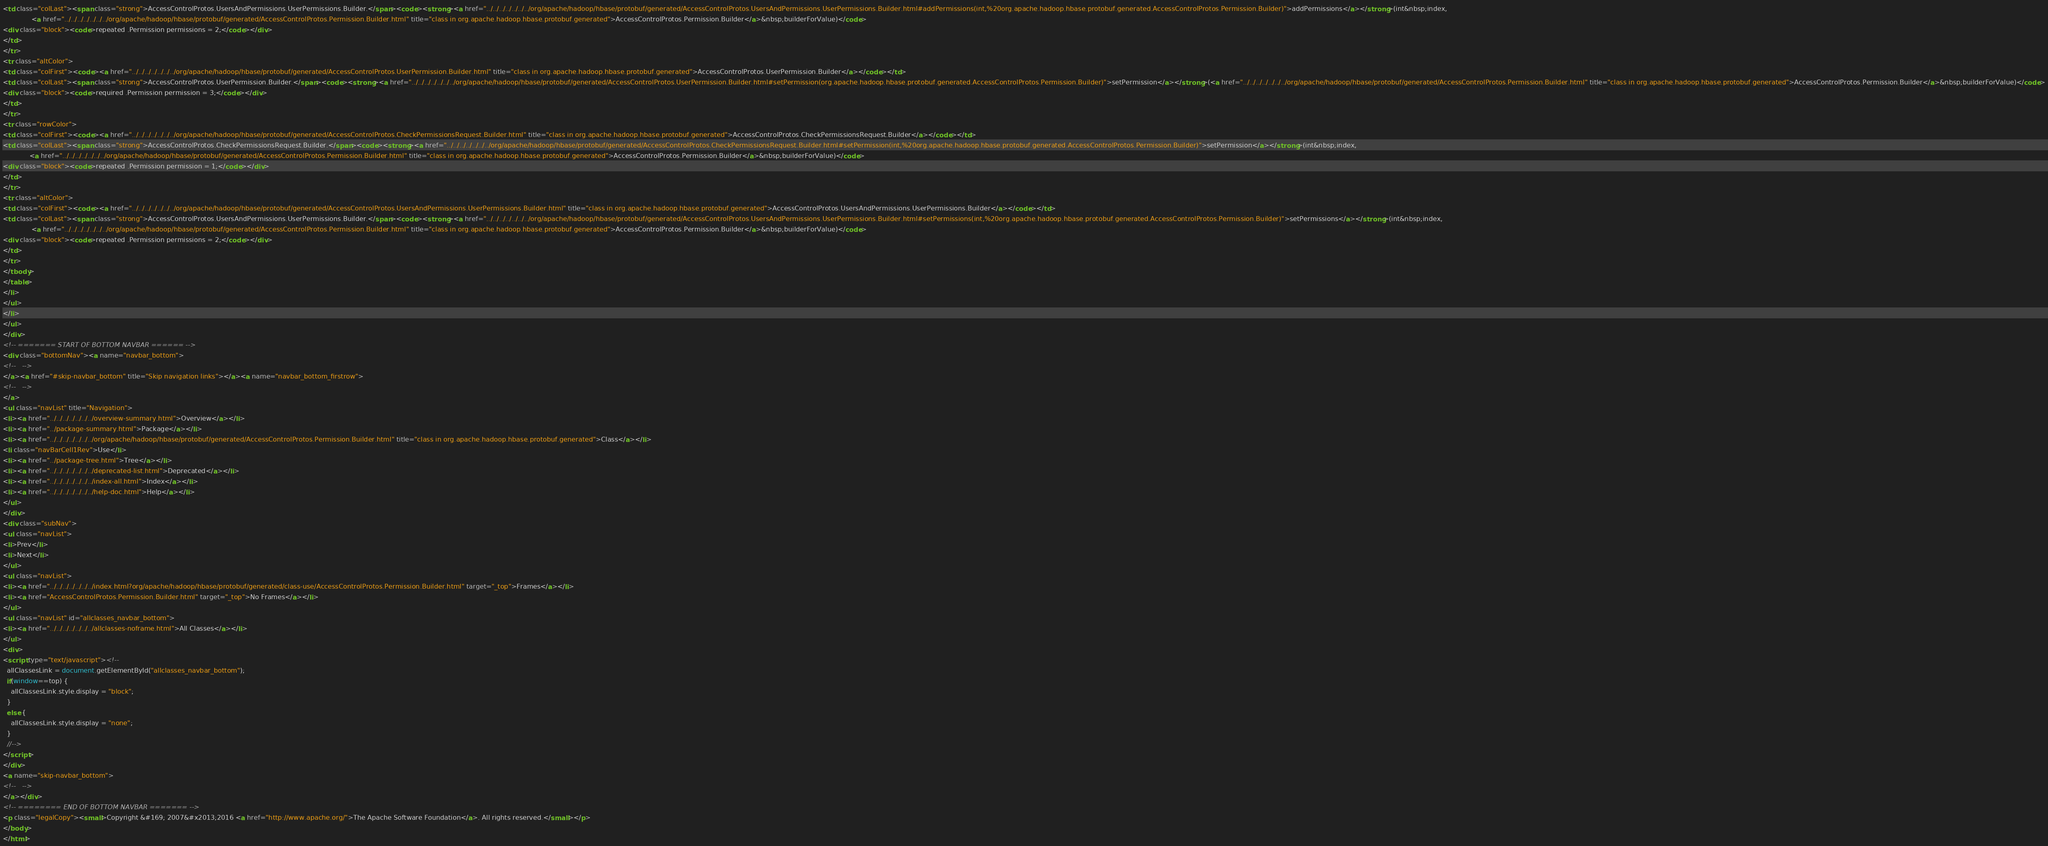<code> <loc_0><loc_0><loc_500><loc_500><_HTML_><td class="colLast"><span class="strong">AccessControlProtos.UsersAndPermissions.UserPermissions.Builder.</span><code><strong><a href="../../../../../../../org/apache/hadoop/hbase/protobuf/generated/AccessControlProtos.UsersAndPermissions.UserPermissions.Builder.html#addPermissions(int,%20org.apache.hadoop.hbase.protobuf.generated.AccessControlProtos.Permission.Builder)">addPermissions</a></strong>(int&nbsp;index,
              <a href="../../../../../../../org/apache/hadoop/hbase/protobuf/generated/AccessControlProtos.Permission.Builder.html" title="class in org.apache.hadoop.hbase.protobuf.generated">AccessControlProtos.Permission.Builder</a>&nbsp;builderForValue)</code>
<div class="block"><code>repeated .Permission permissions = 2;</code></div>
</td>
</tr>
<tr class="altColor">
<td class="colFirst"><code><a href="../../../../../../../org/apache/hadoop/hbase/protobuf/generated/AccessControlProtos.UserPermission.Builder.html" title="class in org.apache.hadoop.hbase.protobuf.generated">AccessControlProtos.UserPermission.Builder</a></code></td>
<td class="colLast"><span class="strong">AccessControlProtos.UserPermission.Builder.</span><code><strong><a href="../../../../../../../org/apache/hadoop/hbase/protobuf/generated/AccessControlProtos.UserPermission.Builder.html#setPermission(org.apache.hadoop.hbase.protobuf.generated.AccessControlProtos.Permission.Builder)">setPermission</a></strong>(<a href="../../../../../../../org/apache/hadoop/hbase/protobuf/generated/AccessControlProtos.Permission.Builder.html" title="class in org.apache.hadoop.hbase.protobuf.generated">AccessControlProtos.Permission.Builder</a>&nbsp;builderForValue)</code>
<div class="block"><code>required .Permission permission = 3;</code></div>
</td>
</tr>
<tr class="rowColor">
<td class="colFirst"><code><a href="../../../../../../../org/apache/hadoop/hbase/protobuf/generated/AccessControlProtos.CheckPermissionsRequest.Builder.html" title="class in org.apache.hadoop.hbase.protobuf.generated">AccessControlProtos.CheckPermissionsRequest.Builder</a></code></td>
<td class="colLast"><span class="strong">AccessControlProtos.CheckPermissionsRequest.Builder.</span><code><strong><a href="../../../../../../../org/apache/hadoop/hbase/protobuf/generated/AccessControlProtos.CheckPermissionsRequest.Builder.html#setPermission(int,%20org.apache.hadoop.hbase.protobuf.generated.AccessControlProtos.Permission.Builder)">setPermission</a></strong>(int&nbsp;index,
             <a href="../../../../../../../org/apache/hadoop/hbase/protobuf/generated/AccessControlProtos.Permission.Builder.html" title="class in org.apache.hadoop.hbase.protobuf.generated">AccessControlProtos.Permission.Builder</a>&nbsp;builderForValue)</code>
<div class="block"><code>repeated .Permission permission = 1;</code></div>
</td>
</tr>
<tr class="altColor">
<td class="colFirst"><code><a href="../../../../../../../org/apache/hadoop/hbase/protobuf/generated/AccessControlProtos.UsersAndPermissions.UserPermissions.Builder.html" title="class in org.apache.hadoop.hbase.protobuf.generated">AccessControlProtos.UsersAndPermissions.UserPermissions.Builder</a></code></td>
<td class="colLast"><span class="strong">AccessControlProtos.UsersAndPermissions.UserPermissions.Builder.</span><code><strong><a href="../../../../../../../org/apache/hadoop/hbase/protobuf/generated/AccessControlProtos.UsersAndPermissions.UserPermissions.Builder.html#setPermissions(int,%20org.apache.hadoop.hbase.protobuf.generated.AccessControlProtos.Permission.Builder)">setPermissions</a></strong>(int&nbsp;index,
              <a href="../../../../../../../org/apache/hadoop/hbase/protobuf/generated/AccessControlProtos.Permission.Builder.html" title="class in org.apache.hadoop.hbase.protobuf.generated">AccessControlProtos.Permission.Builder</a>&nbsp;builderForValue)</code>
<div class="block"><code>repeated .Permission permissions = 2;</code></div>
</td>
</tr>
</tbody>
</table>
</li>
</ul>
</li>
</ul>
</div>
<!-- ======= START OF BOTTOM NAVBAR ====== -->
<div class="bottomNav"><a name="navbar_bottom">
<!--   -->
</a><a href="#skip-navbar_bottom" title="Skip navigation links"></a><a name="navbar_bottom_firstrow">
<!--   -->
</a>
<ul class="navList" title="Navigation">
<li><a href="../../../../../../../overview-summary.html">Overview</a></li>
<li><a href="../package-summary.html">Package</a></li>
<li><a href="../../../../../../../org/apache/hadoop/hbase/protobuf/generated/AccessControlProtos.Permission.Builder.html" title="class in org.apache.hadoop.hbase.protobuf.generated">Class</a></li>
<li class="navBarCell1Rev">Use</li>
<li><a href="../package-tree.html">Tree</a></li>
<li><a href="../../../../../../../deprecated-list.html">Deprecated</a></li>
<li><a href="../../../../../../../index-all.html">Index</a></li>
<li><a href="../../../../../../../help-doc.html">Help</a></li>
</ul>
</div>
<div class="subNav">
<ul class="navList">
<li>Prev</li>
<li>Next</li>
</ul>
<ul class="navList">
<li><a href="../../../../../../../index.html?org/apache/hadoop/hbase/protobuf/generated/class-use/AccessControlProtos.Permission.Builder.html" target="_top">Frames</a></li>
<li><a href="AccessControlProtos.Permission.Builder.html" target="_top">No Frames</a></li>
</ul>
<ul class="navList" id="allclasses_navbar_bottom">
<li><a href="../../../../../../../allclasses-noframe.html">All Classes</a></li>
</ul>
<div>
<script type="text/javascript"><!--
  allClassesLink = document.getElementById("allclasses_navbar_bottom");
  if(window==top) {
    allClassesLink.style.display = "block";
  }
  else {
    allClassesLink.style.display = "none";
  }
  //-->
</script>
</div>
<a name="skip-navbar_bottom">
<!--   -->
</a></div>
<!-- ======== END OF BOTTOM NAVBAR ======= -->
<p class="legalCopy"><small>Copyright &#169; 2007&#x2013;2016 <a href="http://www.apache.org/">The Apache Software Foundation</a>. All rights reserved.</small></p>
</body>
</html>
</code> 